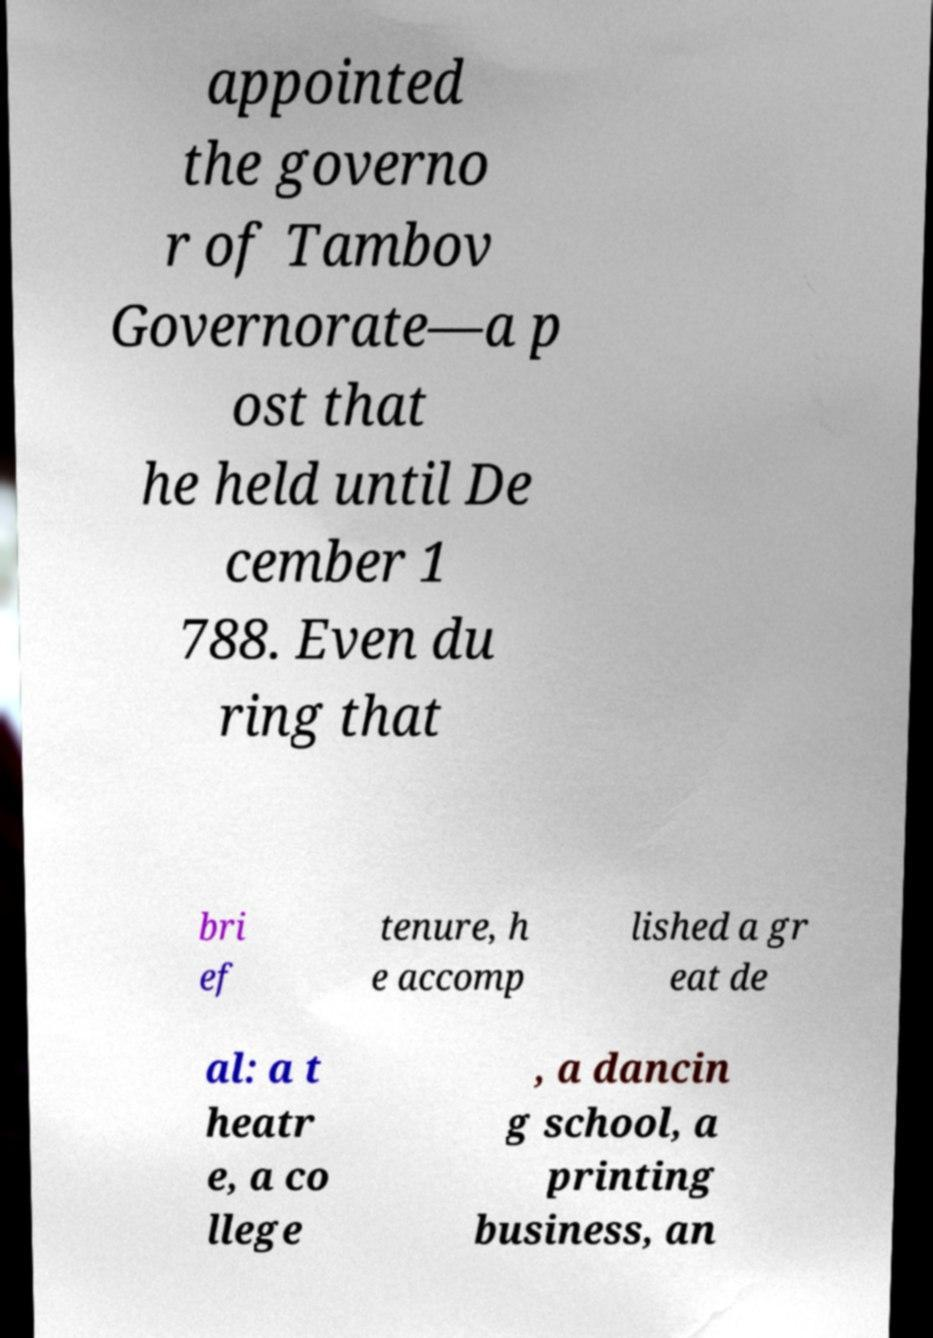Please read and relay the text visible in this image. What does it say? appointed the governo r of Tambov Governorate—a p ost that he held until De cember 1 788. Even du ring that bri ef tenure, h e accomp lished a gr eat de al: a t heatr e, a co llege , a dancin g school, a printing business, an 